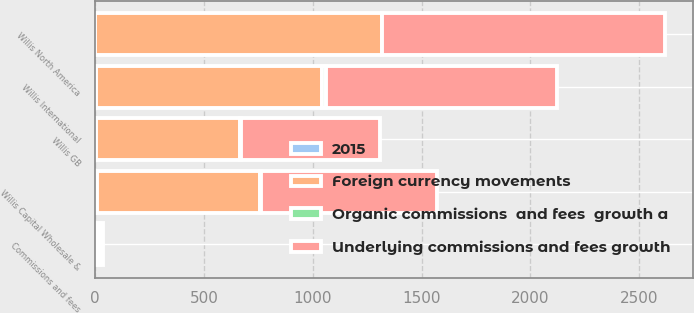<chart> <loc_0><loc_0><loc_500><loc_500><stacked_bar_chart><ecel><fcel>Willis GB<fcel>Willis Capital Wholesale &<fcel>Willis North America<fcel>Willis International<fcel>Commissions and fees<nl><fcel>Underlying commissions and fees growth<fcel>637<fcel>811<fcel>1298<fcel>1063<fcel>13.5<nl><fcel>Foreign currency movements<fcel>662<fcel>749<fcel>1318<fcel>1038<fcel>13.5<nl><fcel>2015<fcel>3.8<fcel>8.3<fcel>1.5<fcel>2.4<fcel>1.1<nl><fcel>Organic commissions  and fees  growth a<fcel>5.4<fcel>4.2<fcel>0.4<fcel>18.7<fcel>6.5<nl></chart> 